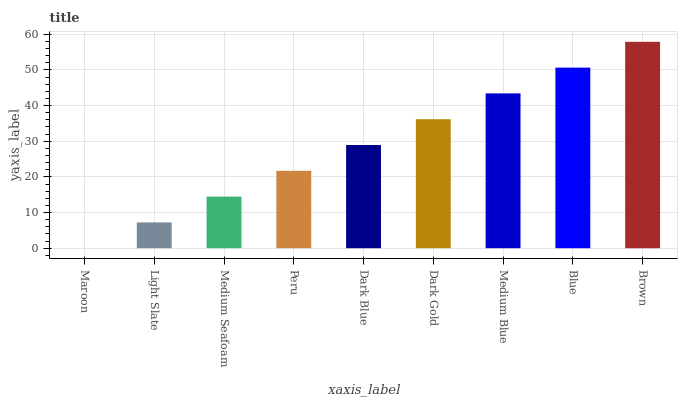Is Maroon the minimum?
Answer yes or no. Yes. Is Brown the maximum?
Answer yes or no. Yes. Is Light Slate the minimum?
Answer yes or no. No. Is Light Slate the maximum?
Answer yes or no. No. Is Light Slate greater than Maroon?
Answer yes or no. Yes. Is Maroon less than Light Slate?
Answer yes or no. Yes. Is Maroon greater than Light Slate?
Answer yes or no. No. Is Light Slate less than Maroon?
Answer yes or no. No. Is Dark Blue the high median?
Answer yes or no. Yes. Is Dark Blue the low median?
Answer yes or no. Yes. Is Blue the high median?
Answer yes or no. No. Is Dark Gold the low median?
Answer yes or no. No. 